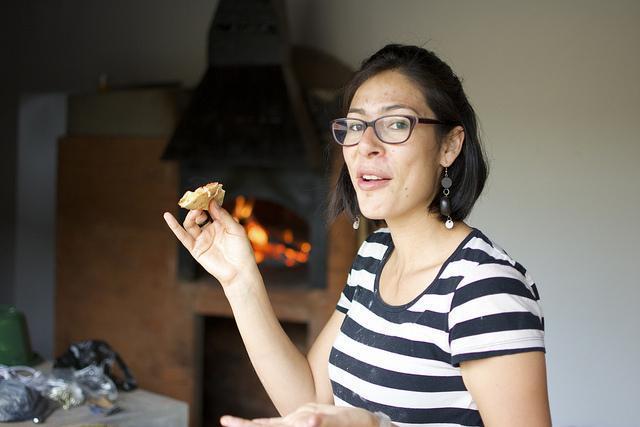Is "The person is at the left side of the pizza." an appropriate description for the image?
Answer yes or no. Yes. 